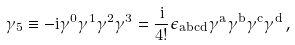<formula> <loc_0><loc_0><loc_500><loc_500>\gamma _ { 5 } \equiv - i \gamma ^ { 0 } \gamma ^ { 1 } \gamma ^ { 2 } \gamma ^ { 3 } = { \frac { i } { 4 ! } } \epsilon _ { a b c d } \gamma ^ { a } \gamma ^ { b } \gamma ^ { c } \gamma ^ { d } \, ,</formula> 